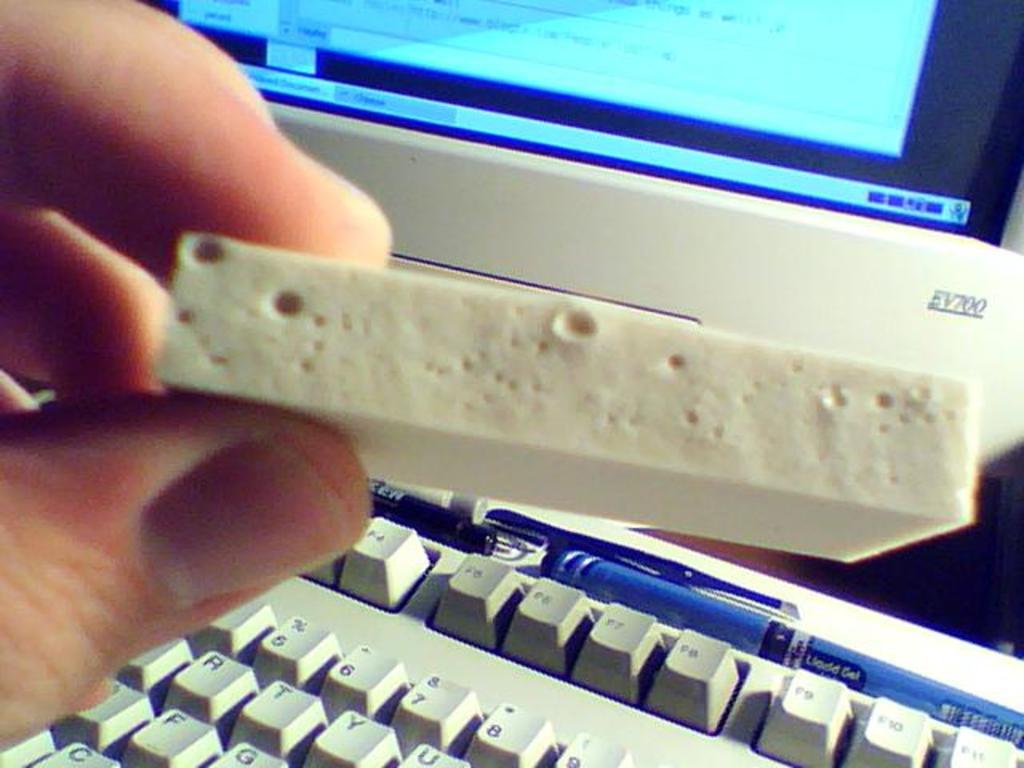What model is the device in the background?
Make the answer very short. Ev700. Is that a blue liquid gel ink pen?
Give a very brief answer. Yes. 